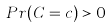<formula> <loc_0><loc_0><loc_500><loc_500>P r ( C = c ) > 0</formula> 